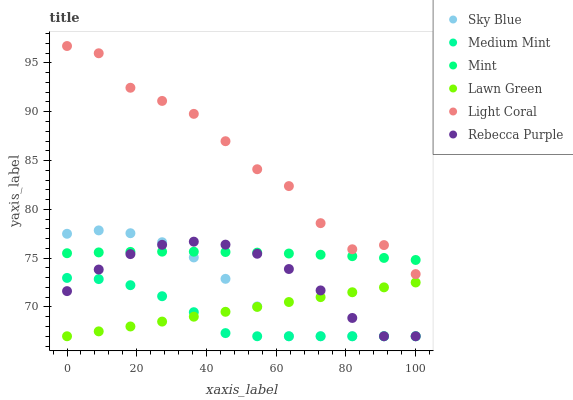Does Medium Mint have the minimum area under the curve?
Answer yes or no. Yes. Does Light Coral have the maximum area under the curve?
Answer yes or no. Yes. Does Lawn Green have the minimum area under the curve?
Answer yes or no. No. Does Lawn Green have the maximum area under the curve?
Answer yes or no. No. Is Lawn Green the smoothest?
Answer yes or no. Yes. Is Light Coral the roughest?
Answer yes or no. Yes. Is Light Coral the smoothest?
Answer yes or no. No. Is Lawn Green the roughest?
Answer yes or no. No. Does Medium Mint have the lowest value?
Answer yes or no. Yes. Does Light Coral have the lowest value?
Answer yes or no. No. Does Light Coral have the highest value?
Answer yes or no. Yes. Does Lawn Green have the highest value?
Answer yes or no. No. Is Rebecca Purple less than Light Coral?
Answer yes or no. Yes. Is Light Coral greater than Sky Blue?
Answer yes or no. Yes. Does Rebecca Purple intersect Lawn Green?
Answer yes or no. Yes. Is Rebecca Purple less than Lawn Green?
Answer yes or no. No. Is Rebecca Purple greater than Lawn Green?
Answer yes or no. No. Does Rebecca Purple intersect Light Coral?
Answer yes or no. No. 